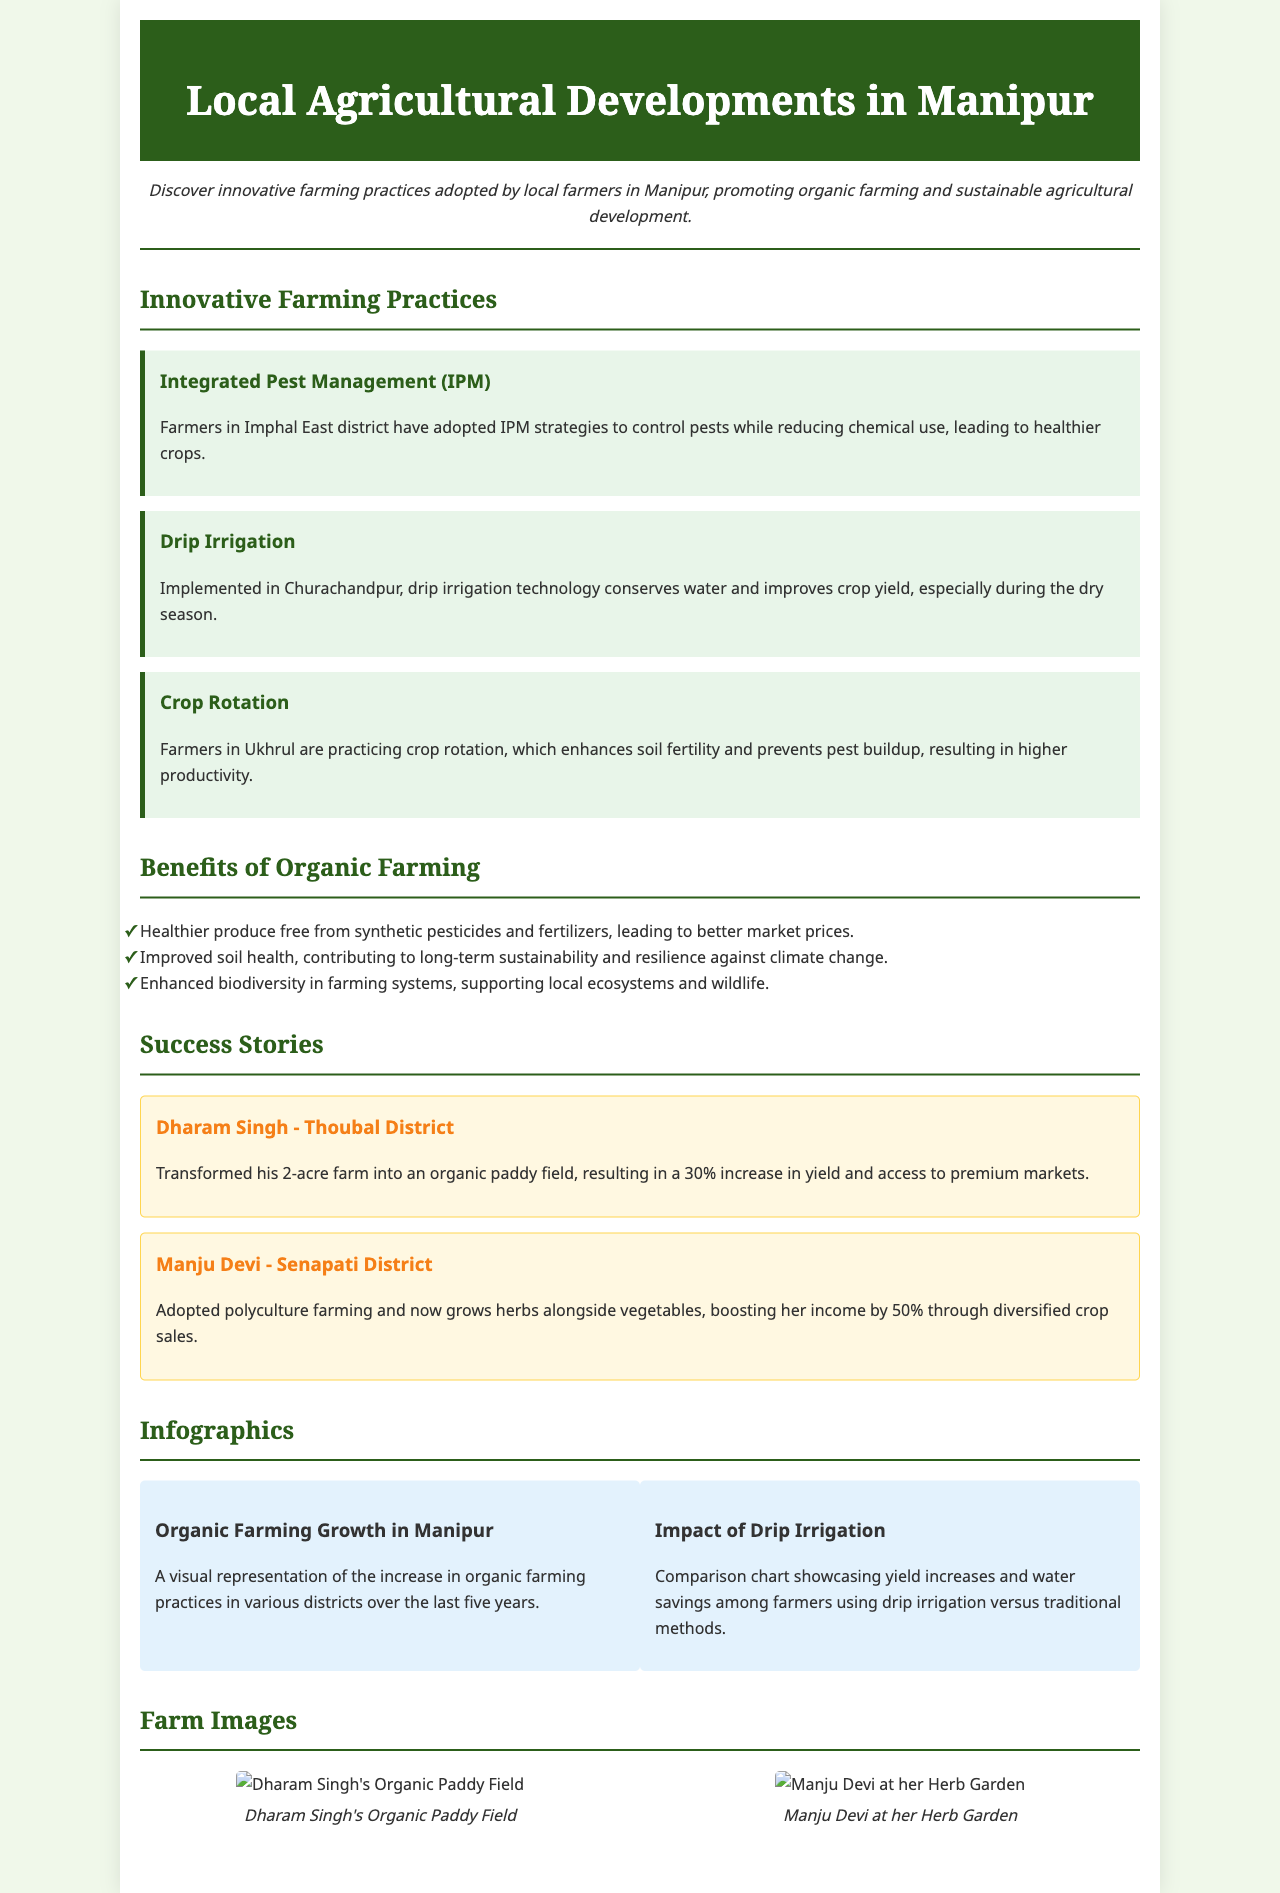What innovative farming practice is adopted in Imphal East district? The document states that Integrated Pest Management (IPM) strategies are adopted in Imphal East district to control pests.
Answer: Integrated Pest Management (IPM) What percentage increase in yield did Dharam Singh achieve? Dharam Singh transformed his farm resulting in a stated 30% increase in yield.
Answer: 30% Which farming method is mentioned to conserve water in Churachandpur? The brochure specifies that drip irrigation technology is implemented in Churachandpur for water conservation.
Answer: Drip Irrigation What is one of the benefits of organic farming listed in the brochure? The document lists multiple benefits, one being "Healthier produce free from synthetic pesticides and fertilizers."
Answer: Healthier produce How much did Manju Devi's income increase after adopting polyculture farming? The success story mentions that Manju Devi's income boosted by 50% after changing her farming method.
Answer: 50% What visual representation is included in the infographics section? The first infographic mentions the increase in organic farming practices in various districts over five years.
Answer: Organic Farming Growth in Manipur What crop does Dharam Singh grow on his farm? The success story specifically states that Dharam Singh transformed his farm into an organic paddy field.
Answer: Organic paddy What aspect of farming do the infographics compare? The document mentions that the infographics include a comparison of yield increases and water savings among farmers.
Answer: Yield increases and water savings 